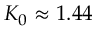Convert formula to latex. <formula><loc_0><loc_0><loc_500><loc_500>K _ { 0 } \approx 1 . 4 4</formula> 